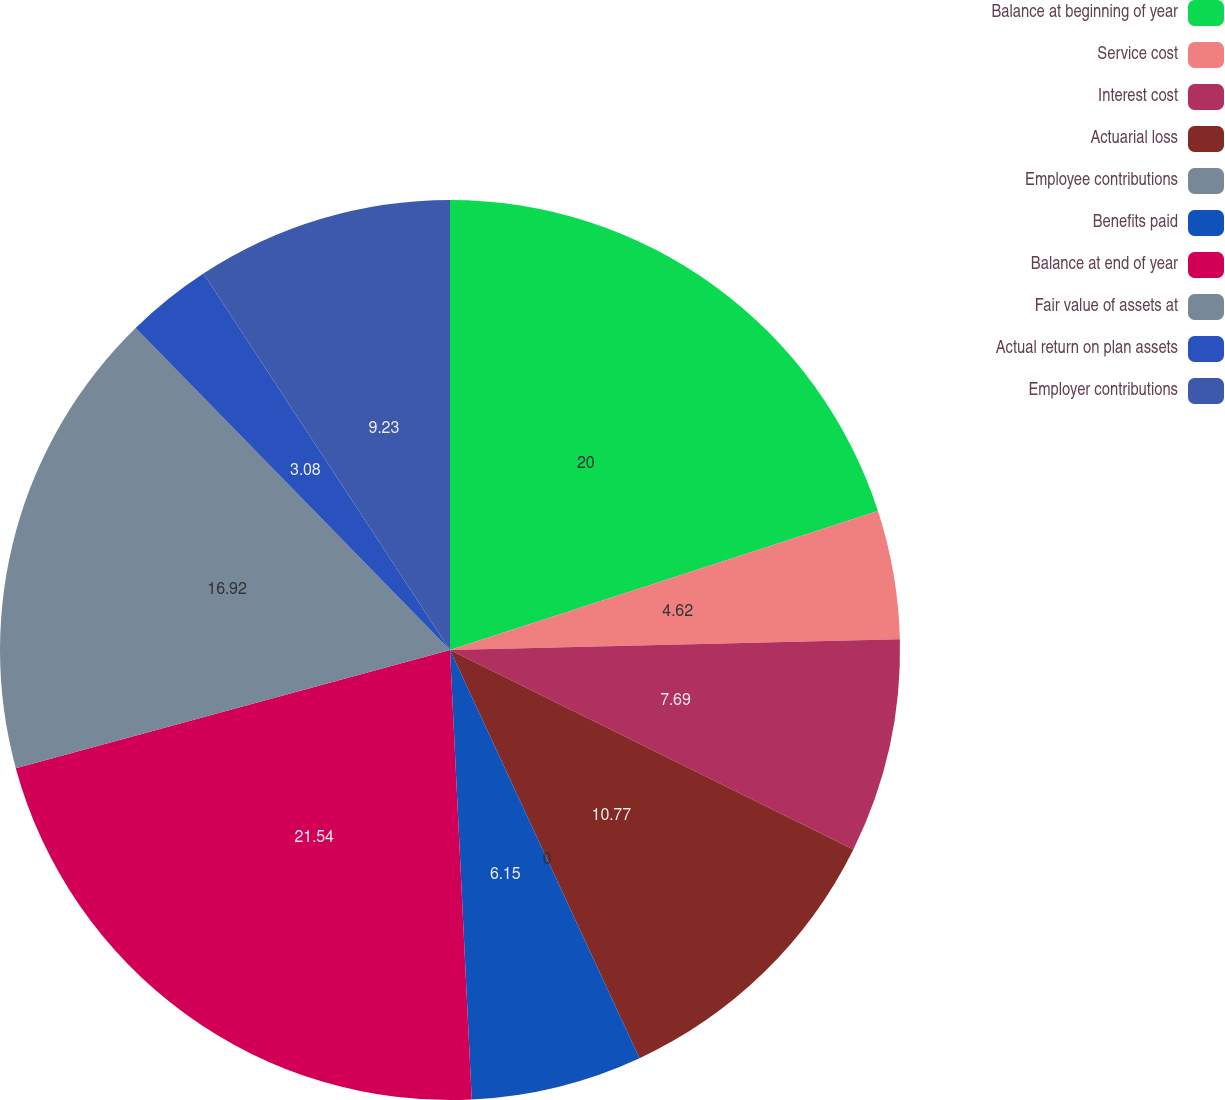<chart> <loc_0><loc_0><loc_500><loc_500><pie_chart><fcel>Balance at beginning of year<fcel>Service cost<fcel>Interest cost<fcel>Actuarial loss<fcel>Employee contributions<fcel>Benefits paid<fcel>Balance at end of year<fcel>Fair value of assets at<fcel>Actual return on plan assets<fcel>Employer contributions<nl><fcel>20.0%<fcel>4.62%<fcel>7.69%<fcel>10.77%<fcel>0.0%<fcel>6.15%<fcel>21.54%<fcel>16.92%<fcel>3.08%<fcel>9.23%<nl></chart> 